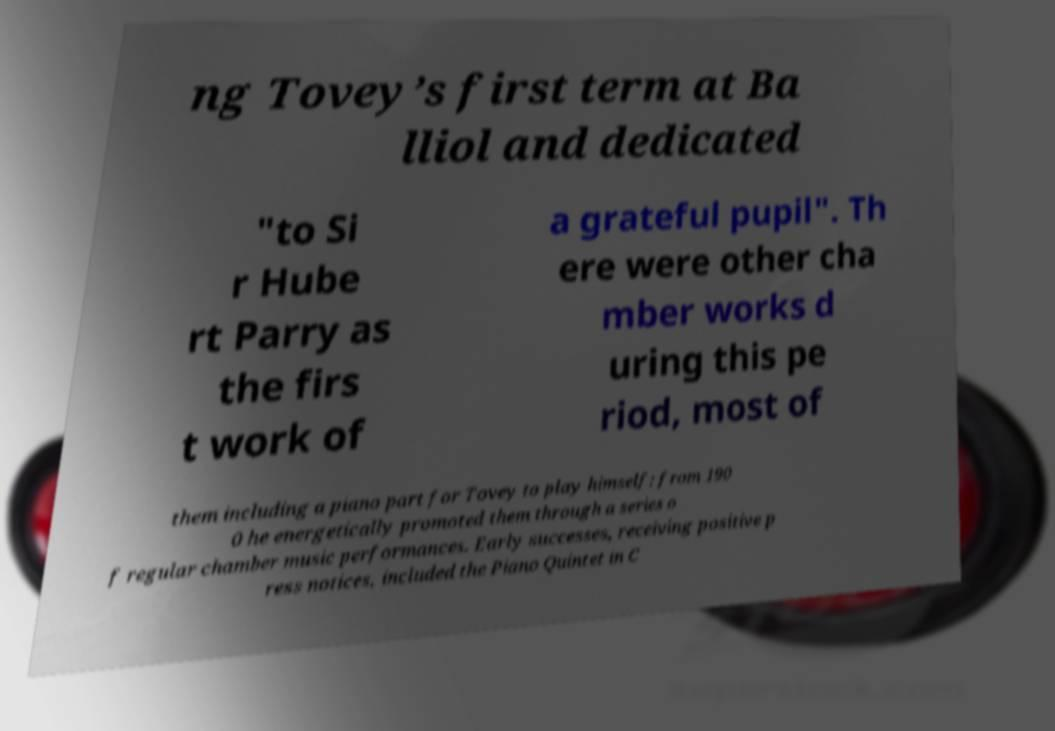I need the written content from this picture converted into text. Can you do that? ng Tovey’s first term at Ba lliol and dedicated "to Si r Hube rt Parry as the firs t work of a grateful pupil". Th ere were other cha mber works d uring this pe riod, most of them including a piano part for Tovey to play himself: from 190 0 he energetically promoted them through a series o f regular chamber music performances. Early successes, receiving positive p ress notices, included the Piano Quintet in C 